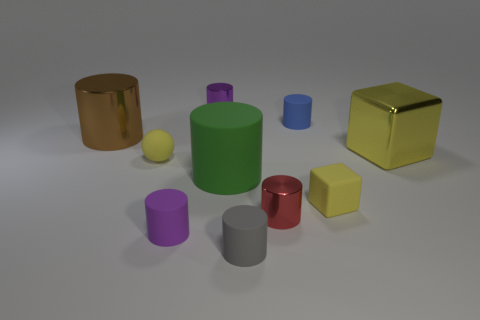Subtract all brown cylinders. How many cylinders are left? 6 Subtract all purple cylinders. How many cylinders are left? 5 Subtract all red spheres. Subtract all purple cylinders. How many spheres are left? 1 Subtract all cubes. How many objects are left? 8 Add 9 green cylinders. How many green cylinders are left? 10 Add 3 large purple metal cubes. How many large purple metal cubes exist? 3 Subtract 0 green spheres. How many objects are left? 10 Subtract all large brown metallic cylinders. Subtract all small gray things. How many objects are left? 8 